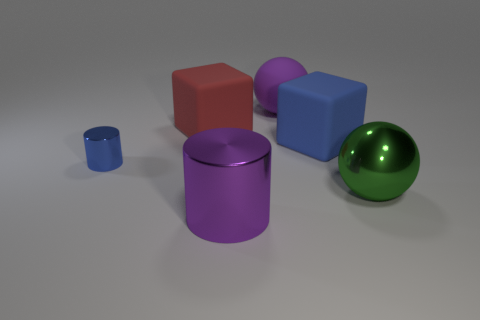Add 2 big blue matte blocks. How many objects exist? 8 Subtract all spheres. How many objects are left? 4 Add 2 blue objects. How many blue objects exist? 4 Subtract 0 green blocks. How many objects are left? 6 Subtract all purple metal cylinders. Subtract all cubes. How many objects are left? 3 Add 3 large green spheres. How many large green spheres are left? 4 